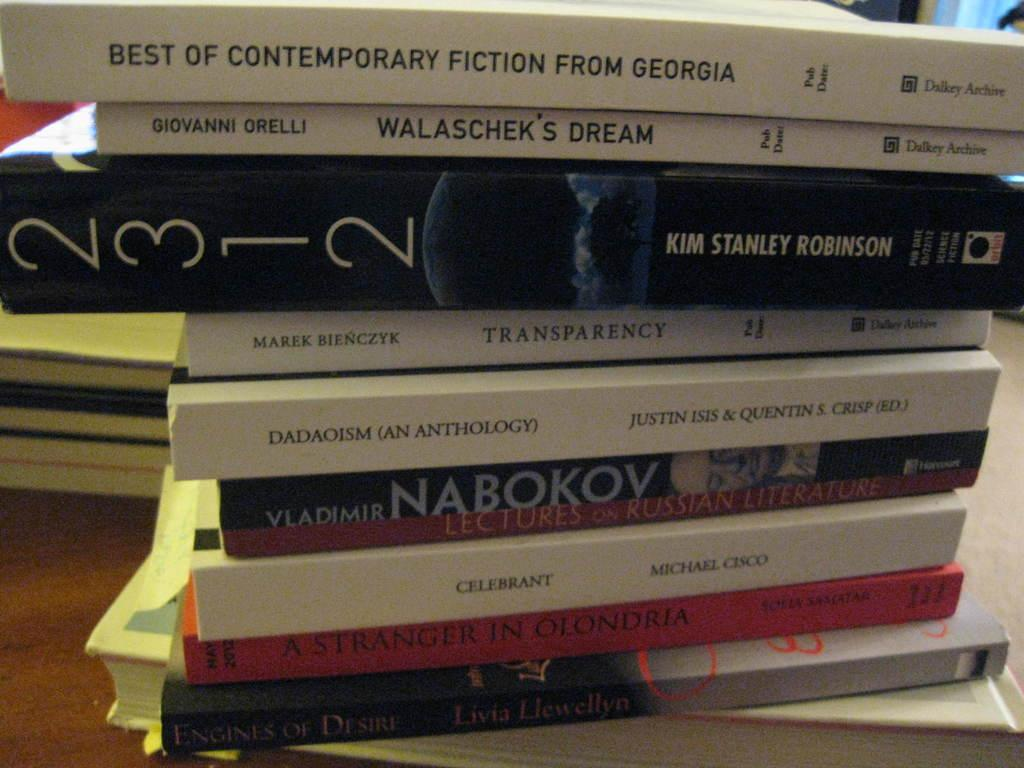What is covering the floor in the image? There are dozens of books on the floor in the image. Can you describe the setting where the image was taken? The image may have been taken in a hall. What type of memory is being used by the books in the image? The books in the image do not have memory, as they are physical objects and not capable of memory storage. 